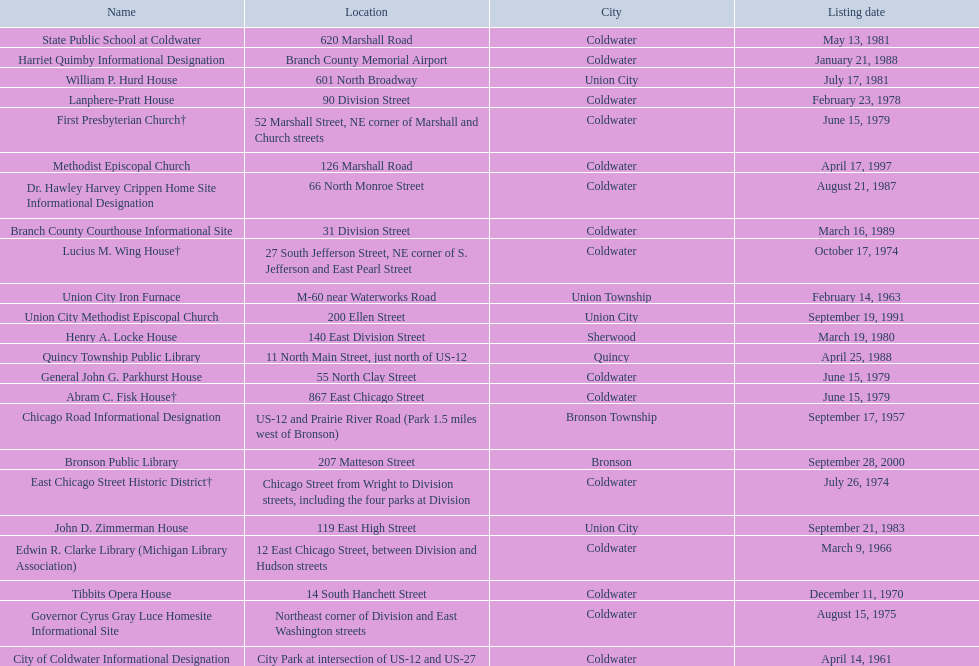Help me parse the entirety of this table. {'header': ['Name', 'Location', 'City', 'Listing date'], 'rows': [['State Public School at Coldwater', '620 Marshall Road', 'Coldwater', 'May 13, 1981'], ['Harriet Quimby Informational Designation', 'Branch County Memorial Airport', 'Coldwater', 'January 21, 1988'], ['William P. Hurd House', '601 North Broadway', 'Union City', 'July 17, 1981'], ['Lanphere-Pratt House', '90 Division Street', 'Coldwater', 'February 23, 1978'], ['First Presbyterian Church†', '52 Marshall Street, NE corner of Marshall and Church streets', 'Coldwater', 'June 15, 1979'], ['Methodist Episcopal Church', '126 Marshall Road', 'Coldwater', 'April 17, 1997'], ['Dr. Hawley Harvey Crippen Home Site Informational Designation', '66 North Monroe Street', 'Coldwater', 'August 21, 1987'], ['Branch County Courthouse Informational Site', '31 Division Street', 'Coldwater', 'March 16, 1989'], ['Lucius M. Wing House†', '27 South Jefferson Street, NE corner of S. Jefferson and East Pearl Street', 'Coldwater', 'October 17, 1974'], ['Union City Iron Furnace', 'M-60 near Waterworks Road', 'Union Township', 'February 14, 1963'], ['Union City Methodist Episcopal Church', '200 Ellen Street', 'Union City', 'September 19, 1991'], ['Henry A. Locke House', '140 East Division Street', 'Sherwood', 'March 19, 1980'], ['Quincy Township Public Library', '11 North Main Street, just north of US-12', 'Quincy', 'April 25, 1988'], ['General John G. Parkhurst House', '55 North Clay Street', 'Coldwater', 'June 15, 1979'], ['Abram C. Fisk House†', '867 East Chicago Street', 'Coldwater', 'June 15, 1979'], ['Chicago Road Informational Designation', 'US-12 and Prairie River Road (Park 1.5 miles west of Bronson)', 'Bronson Township', 'September 17, 1957'], ['Bronson Public Library', '207 Matteson Street', 'Bronson', 'September 28, 2000'], ['East Chicago Street Historic District†', 'Chicago Street from Wright to Division streets, including the four parks at Division', 'Coldwater', 'July 26, 1974'], ['John D. Zimmerman House', '119 East High Street', 'Union City', 'September 21, 1983'], ['Edwin R. Clarke Library (Michigan Library Association)', '12 East Chicago Street, between Division and Hudson streets', 'Coldwater', 'March 9, 1966'], ['Tibbits Opera House', '14 South Hanchett Street', 'Coldwater', 'December 11, 1970'], ['Governor Cyrus Gray Luce Homesite Informational Site', 'Northeast corner of Division and East Washington streets', 'Coldwater', 'August 15, 1975'], ['City of Coldwater Informational Designation', 'City Park at intersection of US-12 and US-27', 'Coldwater', 'April 14, 1961']]} Name a site that was listed no later than 1960. Chicago Road Informational Designation. 